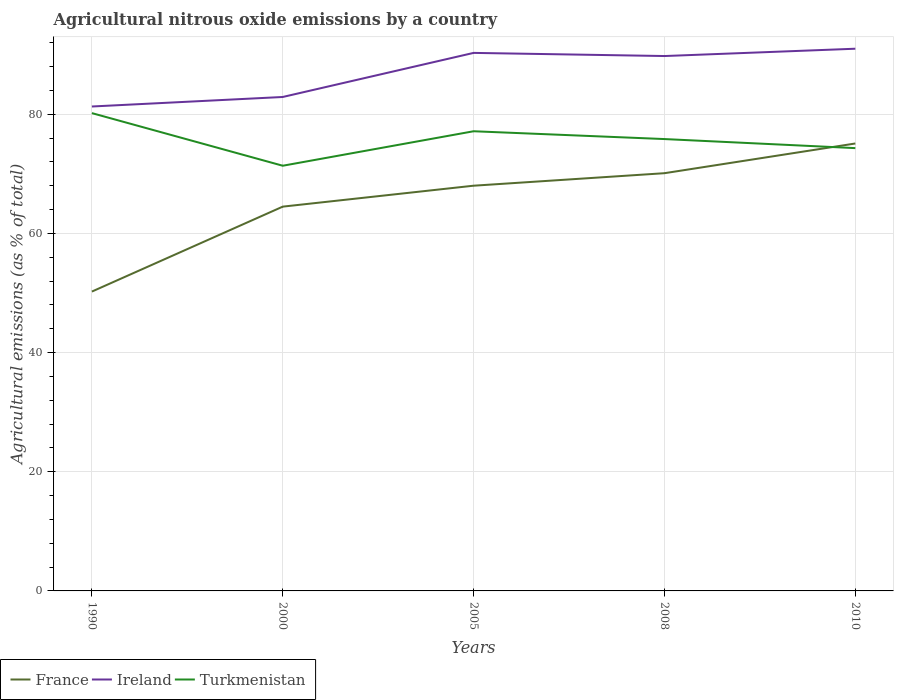Does the line corresponding to France intersect with the line corresponding to Ireland?
Ensure brevity in your answer.  No. Is the number of lines equal to the number of legend labels?
Offer a very short reply. Yes. Across all years, what is the maximum amount of agricultural nitrous oxide emitted in France?
Provide a short and direct response. 50.25. What is the total amount of agricultural nitrous oxide emitted in Ireland in the graph?
Ensure brevity in your answer.  -1.23. What is the difference between the highest and the second highest amount of agricultural nitrous oxide emitted in Ireland?
Make the answer very short. 9.7. Is the amount of agricultural nitrous oxide emitted in Ireland strictly greater than the amount of agricultural nitrous oxide emitted in Turkmenistan over the years?
Your answer should be very brief. No. Does the graph contain any zero values?
Provide a succinct answer. No. Where does the legend appear in the graph?
Your answer should be compact. Bottom left. How many legend labels are there?
Your answer should be compact. 3. How are the legend labels stacked?
Offer a terse response. Horizontal. What is the title of the graph?
Your answer should be compact. Agricultural nitrous oxide emissions by a country. Does "Kyrgyz Republic" appear as one of the legend labels in the graph?
Make the answer very short. No. What is the label or title of the X-axis?
Keep it short and to the point. Years. What is the label or title of the Y-axis?
Your response must be concise. Agricultural emissions (as % of total). What is the Agricultural emissions (as % of total) of France in 1990?
Offer a terse response. 50.25. What is the Agricultural emissions (as % of total) of Ireland in 1990?
Ensure brevity in your answer.  81.31. What is the Agricultural emissions (as % of total) of Turkmenistan in 1990?
Your answer should be very brief. 80.2. What is the Agricultural emissions (as % of total) in France in 2000?
Offer a terse response. 64.5. What is the Agricultural emissions (as % of total) in Ireland in 2000?
Your response must be concise. 82.91. What is the Agricultural emissions (as % of total) in Turkmenistan in 2000?
Your answer should be compact. 71.37. What is the Agricultural emissions (as % of total) of France in 2005?
Offer a very short reply. 68.02. What is the Agricultural emissions (as % of total) in Ireland in 2005?
Ensure brevity in your answer.  90.31. What is the Agricultural emissions (as % of total) of Turkmenistan in 2005?
Your answer should be compact. 77.16. What is the Agricultural emissions (as % of total) of France in 2008?
Your answer should be very brief. 70.12. What is the Agricultural emissions (as % of total) of Ireland in 2008?
Make the answer very short. 89.78. What is the Agricultural emissions (as % of total) in Turkmenistan in 2008?
Provide a short and direct response. 75.84. What is the Agricultural emissions (as % of total) of France in 2010?
Your response must be concise. 75.1. What is the Agricultural emissions (as % of total) in Ireland in 2010?
Make the answer very short. 91.01. What is the Agricultural emissions (as % of total) in Turkmenistan in 2010?
Your answer should be very brief. 74.32. Across all years, what is the maximum Agricultural emissions (as % of total) in France?
Your response must be concise. 75.1. Across all years, what is the maximum Agricultural emissions (as % of total) of Ireland?
Provide a short and direct response. 91.01. Across all years, what is the maximum Agricultural emissions (as % of total) of Turkmenistan?
Offer a very short reply. 80.2. Across all years, what is the minimum Agricultural emissions (as % of total) of France?
Make the answer very short. 50.25. Across all years, what is the minimum Agricultural emissions (as % of total) in Ireland?
Offer a terse response. 81.31. Across all years, what is the minimum Agricultural emissions (as % of total) in Turkmenistan?
Your response must be concise. 71.37. What is the total Agricultural emissions (as % of total) of France in the graph?
Offer a terse response. 327.98. What is the total Agricultural emissions (as % of total) of Ireland in the graph?
Offer a very short reply. 435.31. What is the total Agricultural emissions (as % of total) in Turkmenistan in the graph?
Your answer should be compact. 378.89. What is the difference between the Agricultural emissions (as % of total) of France in 1990 and that in 2000?
Ensure brevity in your answer.  -14.26. What is the difference between the Agricultural emissions (as % of total) of Ireland in 1990 and that in 2000?
Your answer should be compact. -1.6. What is the difference between the Agricultural emissions (as % of total) of Turkmenistan in 1990 and that in 2000?
Your response must be concise. 8.83. What is the difference between the Agricultural emissions (as % of total) of France in 1990 and that in 2005?
Keep it short and to the point. -17.77. What is the difference between the Agricultural emissions (as % of total) in Ireland in 1990 and that in 2005?
Your response must be concise. -9. What is the difference between the Agricultural emissions (as % of total) in Turkmenistan in 1990 and that in 2005?
Your answer should be compact. 3.04. What is the difference between the Agricultural emissions (as % of total) in France in 1990 and that in 2008?
Your answer should be very brief. -19.87. What is the difference between the Agricultural emissions (as % of total) in Ireland in 1990 and that in 2008?
Your response must be concise. -8.47. What is the difference between the Agricultural emissions (as % of total) of Turkmenistan in 1990 and that in 2008?
Provide a succinct answer. 4.36. What is the difference between the Agricultural emissions (as % of total) of France in 1990 and that in 2010?
Your answer should be very brief. -24.86. What is the difference between the Agricultural emissions (as % of total) of Ireland in 1990 and that in 2010?
Offer a terse response. -9.7. What is the difference between the Agricultural emissions (as % of total) of Turkmenistan in 1990 and that in 2010?
Provide a short and direct response. 5.87. What is the difference between the Agricultural emissions (as % of total) of France in 2000 and that in 2005?
Offer a terse response. -3.51. What is the difference between the Agricultural emissions (as % of total) of Ireland in 2000 and that in 2005?
Give a very brief answer. -7.4. What is the difference between the Agricultural emissions (as % of total) of Turkmenistan in 2000 and that in 2005?
Keep it short and to the point. -5.79. What is the difference between the Agricultural emissions (as % of total) of France in 2000 and that in 2008?
Your response must be concise. -5.61. What is the difference between the Agricultural emissions (as % of total) of Ireland in 2000 and that in 2008?
Provide a succinct answer. -6.87. What is the difference between the Agricultural emissions (as % of total) in Turkmenistan in 2000 and that in 2008?
Ensure brevity in your answer.  -4.48. What is the difference between the Agricultural emissions (as % of total) in France in 2000 and that in 2010?
Offer a terse response. -10.6. What is the difference between the Agricultural emissions (as % of total) of Ireland in 2000 and that in 2010?
Provide a succinct answer. -8.1. What is the difference between the Agricultural emissions (as % of total) of Turkmenistan in 2000 and that in 2010?
Your answer should be compact. -2.96. What is the difference between the Agricultural emissions (as % of total) of France in 2005 and that in 2008?
Your response must be concise. -2.1. What is the difference between the Agricultural emissions (as % of total) in Ireland in 2005 and that in 2008?
Offer a very short reply. 0.53. What is the difference between the Agricultural emissions (as % of total) in Turkmenistan in 2005 and that in 2008?
Your response must be concise. 1.31. What is the difference between the Agricultural emissions (as % of total) in France in 2005 and that in 2010?
Your answer should be very brief. -7.09. What is the difference between the Agricultural emissions (as % of total) of Ireland in 2005 and that in 2010?
Make the answer very short. -0.7. What is the difference between the Agricultural emissions (as % of total) in Turkmenistan in 2005 and that in 2010?
Your answer should be compact. 2.83. What is the difference between the Agricultural emissions (as % of total) in France in 2008 and that in 2010?
Provide a succinct answer. -4.99. What is the difference between the Agricultural emissions (as % of total) in Ireland in 2008 and that in 2010?
Ensure brevity in your answer.  -1.23. What is the difference between the Agricultural emissions (as % of total) in Turkmenistan in 2008 and that in 2010?
Offer a terse response. 1.52. What is the difference between the Agricultural emissions (as % of total) in France in 1990 and the Agricultural emissions (as % of total) in Ireland in 2000?
Make the answer very short. -32.66. What is the difference between the Agricultural emissions (as % of total) in France in 1990 and the Agricultural emissions (as % of total) in Turkmenistan in 2000?
Provide a succinct answer. -21.12. What is the difference between the Agricultural emissions (as % of total) of Ireland in 1990 and the Agricultural emissions (as % of total) of Turkmenistan in 2000?
Your answer should be very brief. 9.94. What is the difference between the Agricultural emissions (as % of total) in France in 1990 and the Agricultural emissions (as % of total) in Ireland in 2005?
Offer a terse response. -40.06. What is the difference between the Agricultural emissions (as % of total) of France in 1990 and the Agricultural emissions (as % of total) of Turkmenistan in 2005?
Provide a succinct answer. -26.91. What is the difference between the Agricultural emissions (as % of total) of Ireland in 1990 and the Agricultural emissions (as % of total) of Turkmenistan in 2005?
Make the answer very short. 4.16. What is the difference between the Agricultural emissions (as % of total) in France in 1990 and the Agricultural emissions (as % of total) in Ireland in 2008?
Offer a terse response. -39.53. What is the difference between the Agricultural emissions (as % of total) in France in 1990 and the Agricultural emissions (as % of total) in Turkmenistan in 2008?
Offer a very short reply. -25.6. What is the difference between the Agricultural emissions (as % of total) in Ireland in 1990 and the Agricultural emissions (as % of total) in Turkmenistan in 2008?
Your response must be concise. 5.47. What is the difference between the Agricultural emissions (as % of total) in France in 1990 and the Agricultural emissions (as % of total) in Ireland in 2010?
Provide a succinct answer. -40.76. What is the difference between the Agricultural emissions (as % of total) of France in 1990 and the Agricultural emissions (as % of total) of Turkmenistan in 2010?
Make the answer very short. -24.08. What is the difference between the Agricultural emissions (as % of total) of Ireland in 1990 and the Agricultural emissions (as % of total) of Turkmenistan in 2010?
Your answer should be very brief. 6.99. What is the difference between the Agricultural emissions (as % of total) of France in 2000 and the Agricultural emissions (as % of total) of Ireland in 2005?
Make the answer very short. -25.8. What is the difference between the Agricultural emissions (as % of total) of France in 2000 and the Agricultural emissions (as % of total) of Turkmenistan in 2005?
Offer a terse response. -12.65. What is the difference between the Agricultural emissions (as % of total) in Ireland in 2000 and the Agricultural emissions (as % of total) in Turkmenistan in 2005?
Give a very brief answer. 5.75. What is the difference between the Agricultural emissions (as % of total) of France in 2000 and the Agricultural emissions (as % of total) of Ireland in 2008?
Provide a short and direct response. -25.28. What is the difference between the Agricultural emissions (as % of total) of France in 2000 and the Agricultural emissions (as % of total) of Turkmenistan in 2008?
Provide a succinct answer. -11.34. What is the difference between the Agricultural emissions (as % of total) in Ireland in 2000 and the Agricultural emissions (as % of total) in Turkmenistan in 2008?
Your answer should be very brief. 7.06. What is the difference between the Agricultural emissions (as % of total) of France in 2000 and the Agricultural emissions (as % of total) of Ireland in 2010?
Offer a very short reply. -26.51. What is the difference between the Agricultural emissions (as % of total) in France in 2000 and the Agricultural emissions (as % of total) in Turkmenistan in 2010?
Offer a terse response. -9.82. What is the difference between the Agricultural emissions (as % of total) in Ireland in 2000 and the Agricultural emissions (as % of total) in Turkmenistan in 2010?
Keep it short and to the point. 8.58. What is the difference between the Agricultural emissions (as % of total) in France in 2005 and the Agricultural emissions (as % of total) in Ireland in 2008?
Your answer should be compact. -21.76. What is the difference between the Agricultural emissions (as % of total) in France in 2005 and the Agricultural emissions (as % of total) in Turkmenistan in 2008?
Provide a succinct answer. -7.83. What is the difference between the Agricultural emissions (as % of total) in Ireland in 2005 and the Agricultural emissions (as % of total) in Turkmenistan in 2008?
Offer a terse response. 14.46. What is the difference between the Agricultural emissions (as % of total) of France in 2005 and the Agricultural emissions (as % of total) of Ireland in 2010?
Provide a succinct answer. -22.99. What is the difference between the Agricultural emissions (as % of total) of France in 2005 and the Agricultural emissions (as % of total) of Turkmenistan in 2010?
Make the answer very short. -6.31. What is the difference between the Agricultural emissions (as % of total) in Ireland in 2005 and the Agricultural emissions (as % of total) in Turkmenistan in 2010?
Provide a short and direct response. 15.98. What is the difference between the Agricultural emissions (as % of total) of France in 2008 and the Agricultural emissions (as % of total) of Ireland in 2010?
Offer a very short reply. -20.89. What is the difference between the Agricultural emissions (as % of total) in France in 2008 and the Agricultural emissions (as % of total) in Turkmenistan in 2010?
Provide a short and direct response. -4.21. What is the difference between the Agricultural emissions (as % of total) of Ireland in 2008 and the Agricultural emissions (as % of total) of Turkmenistan in 2010?
Offer a very short reply. 15.46. What is the average Agricultural emissions (as % of total) of France per year?
Offer a terse response. 65.6. What is the average Agricultural emissions (as % of total) in Ireland per year?
Provide a short and direct response. 87.06. What is the average Agricultural emissions (as % of total) of Turkmenistan per year?
Make the answer very short. 75.78. In the year 1990, what is the difference between the Agricultural emissions (as % of total) of France and Agricultural emissions (as % of total) of Ireland?
Ensure brevity in your answer.  -31.06. In the year 1990, what is the difference between the Agricultural emissions (as % of total) in France and Agricultural emissions (as % of total) in Turkmenistan?
Ensure brevity in your answer.  -29.95. In the year 1990, what is the difference between the Agricultural emissions (as % of total) in Ireland and Agricultural emissions (as % of total) in Turkmenistan?
Your answer should be compact. 1.11. In the year 2000, what is the difference between the Agricultural emissions (as % of total) of France and Agricultural emissions (as % of total) of Ireland?
Your answer should be very brief. -18.41. In the year 2000, what is the difference between the Agricultural emissions (as % of total) of France and Agricultural emissions (as % of total) of Turkmenistan?
Make the answer very short. -6.86. In the year 2000, what is the difference between the Agricultural emissions (as % of total) of Ireland and Agricultural emissions (as % of total) of Turkmenistan?
Make the answer very short. 11.54. In the year 2005, what is the difference between the Agricultural emissions (as % of total) of France and Agricultural emissions (as % of total) of Ireland?
Your answer should be very brief. -22.29. In the year 2005, what is the difference between the Agricultural emissions (as % of total) in France and Agricultural emissions (as % of total) in Turkmenistan?
Provide a succinct answer. -9.14. In the year 2005, what is the difference between the Agricultural emissions (as % of total) of Ireland and Agricultural emissions (as % of total) of Turkmenistan?
Keep it short and to the point. 13.15. In the year 2008, what is the difference between the Agricultural emissions (as % of total) of France and Agricultural emissions (as % of total) of Ireland?
Provide a succinct answer. -19.66. In the year 2008, what is the difference between the Agricultural emissions (as % of total) of France and Agricultural emissions (as % of total) of Turkmenistan?
Your answer should be compact. -5.73. In the year 2008, what is the difference between the Agricultural emissions (as % of total) in Ireland and Agricultural emissions (as % of total) in Turkmenistan?
Give a very brief answer. 13.94. In the year 2010, what is the difference between the Agricultural emissions (as % of total) in France and Agricultural emissions (as % of total) in Ireland?
Provide a succinct answer. -15.91. In the year 2010, what is the difference between the Agricultural emissions (as % of total) of France and Agricultural emissions (as % of total) of Turkmenistan?
Keep it short and to the point. 0.78. In the year 2010, what is the difference between the Agricultural emissions (as % of total) in Ireland and Agricultural emissions (as % of total) in Turkmenistan?
Keep it short and to the point. 16.68. What is the ratio of the Agricultural emissions (as % of total) of France in 1990 to that in 2000?
Keep it short and to the point. 0.78. What is the ratio of the Agricultural emissions (as % of total) in Ireland in 1990 to that in 2000?
Provide a short and direct response. 0.98. What is the ratio of the Agricultural emissions (as % of total) in Turkmenistan in 1990 to that in 2000?
Your answer should be compact. 1.12. What is the ratio of the Agricultural emissions (as % of total) in France in 1990 to that in 2005?
Your answer should be very brief. 0.74. What is the ratio of the Agricultural emissions (as % of total) in Ireland in 1990 to that in 2005?
Ensure brevity in your answer.  0.9. What is the ratio of the Agricultural emissions (as % of total) in Turkmenistan in 1990 to that in 2005?
Provide a short and direct response. 1.04. What is the ratio of the Agricultural emissions (as % of total) in France in 1990 to that in 2008?
Offer a very short reply. 0.72. What is the ratio of the Agricultural emissions (as % of total) of Ireland in 1990 to that in 2008?
Offer a very short reply. 0.91. What is the ratio of the Agricultural emissions (as % of total) of Turkmenistan in 1990 to that in 2008?
Provide a succinct answer. 1.06. What is the ratio of the Agricultural emissions (as % of total) in France in 1990 to that in 2010?
Offer a terse response. 0.67. What is the ratio of the Agricultural emissions (as % of total) in Ireland in 1990 to that in 2010?
Your response must be concise. 0.89. What is the ratio of the Agricultural emissions (as % of total) of Turkmenistan in 1990 to that in 2010?
Ensure brevity in your answer.  1.08. What is the ratio of the Agricultural emissions (as % of total) in France in 2000 to that in 2005?
Ensure brevity in your answer.  0.95. What is the ratio of the Agricultural emissions (as % of total) in Ireland in 2000 to that in 2005?
Your answer should be compact. 0.92. What is the ratio of the Agricultural emissions (as % of total) of Turkmenistan in 2000 to that in 2005?
Give a very brief answer. 0.93. What is the ratio of the Agricultural emissions (as % of total) in France in 2000 to that in 2008?
Offer a terse response. 0.92. What is the ratio of the Agricultural emissions (as % of total) in Ireland in 2000 to that in 2008?
Provide a succinct answer. 0.92. What is the ratio of the Agricultural emissions (as % of total) in Turkmenistan in 2000 to that in 2008?
Ensure brevity in your answer.  0.94. What is the ratio of the Agricultural emissions (as % of total) in France in 2000 to that in 2010?
Give a very brief answer. 0.86. What is the ratio of the Agricultural emissions (as % of total) of Ireland in 2000 to that in 2010?
Provide a short and direct response. 0.91. What is the ratio of the Agricultural emissions (as % of total) of Turkmenistan in 2000 to that in 2010?
Ensure brevity in your answer.  0.96. What is the ratio of the Agricultural emissions (as % of total) of France in 2005 to that in 2008?
Your answer should be compact. 0.97. What is the ratio of the Agricultural emissions (as % of total) in Ireland in 2005 to that in 2008?
Ensure brevity in your answer.  1.01. What is the ratio of the Agricultural emissions (as % of total) in Turkmenistan in 2005 to that in 2008?
Your answer should be compact. 1.02. What is the ratio of the Agricultural emissions (as % of total) of France in 2005 to that in 2010?
Provide a succinct answer. 0.91. What is the ratio of the Agricultural emissions (as % of total) of Turkmenistan in 2005 to that in 2010?
Offer a terse response. 1.04. What is the ratio of the Agricultural emissions (as % of total) in France in 2008 to that in 2010?
Provide a succinct answer. 0.93. What is the ratio of the Agricultural emissions (as % of total) in Ireland in 2008 to that in 2010?
Provide a succinct answer. 0.99. What is the ratio of the Agricultural emissions (as % of total) in Turkmenistan in 2008 to that in 2010?
Offer a very short reply. 1.02. What is the difference between the highest and the second highest Agricultural emissions (as % of total) of France?
Provide a short and direct response. 4.99. What is the difference between the highest and the second highest Agricultural emissions (as % of total) in Ireland?
Offer a terse response. 0.7. What is the difference between the highest and the second highest Agricultural emissions (as % of total) in Turkmenistan?
Your answer should be compact. 3.04. What is the difference between the highest and the lowest Agricultural emissions (as % of total) in France?
Ensure brevity in your answer.  24.86. What is the difference between the highest and the lowest Agricultural emissions (as % of total) of Ireland?
Ensure brevity in your answer.  9.7. What is the difference between the highest and the lowest Agricultural emissions (as % of total) of Turkmenistan?
Offer a very short reply. 8.83. 